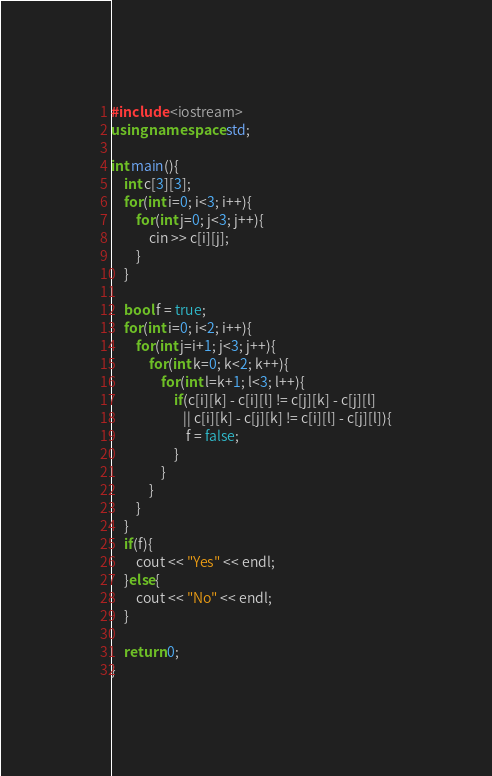Convert code to text. <code><loc_0><loc_0><loc_500><loc_500><_C++_>#include <iostream>
using namespace std;

int main(){
    int c[3][3];
    for(int i=0; i<3; i++){
        for(int j=0; j<3; j++){
            cin >> c[i][j];
        }
    }

    bool f = true;
    for(int i=0; i<2; i++){
        for(int j=i+1; j<3; j++){
            for(int k=0; k<2; k++){
                for(int l=k+1; l<3; l++){
                    if(c[i][k] - c[i][l] != c[j][k] - c[j][l]
                       || c[i][k] - c[j][k] != c[i][l] - c[j][l]){
                        f = false;
                    }
                }
            }       
        }
    }
    if(f){
        cout << "Yes" << endl;
    }else{
        cout << "No" << endl;
    }
  
    return 0;
}
</code> 